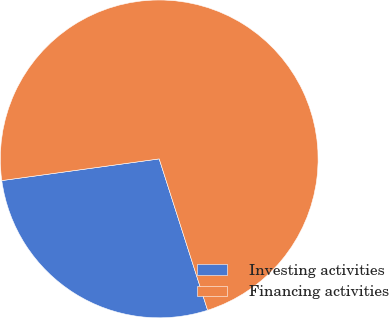<chart> <loc_0><loc_0><loc_500><loc_500><pie_chart><fcel>Investing activities<fcel>Financing activities<nl><fcel>27.75%<fcel>72.25%<nl></chart> 